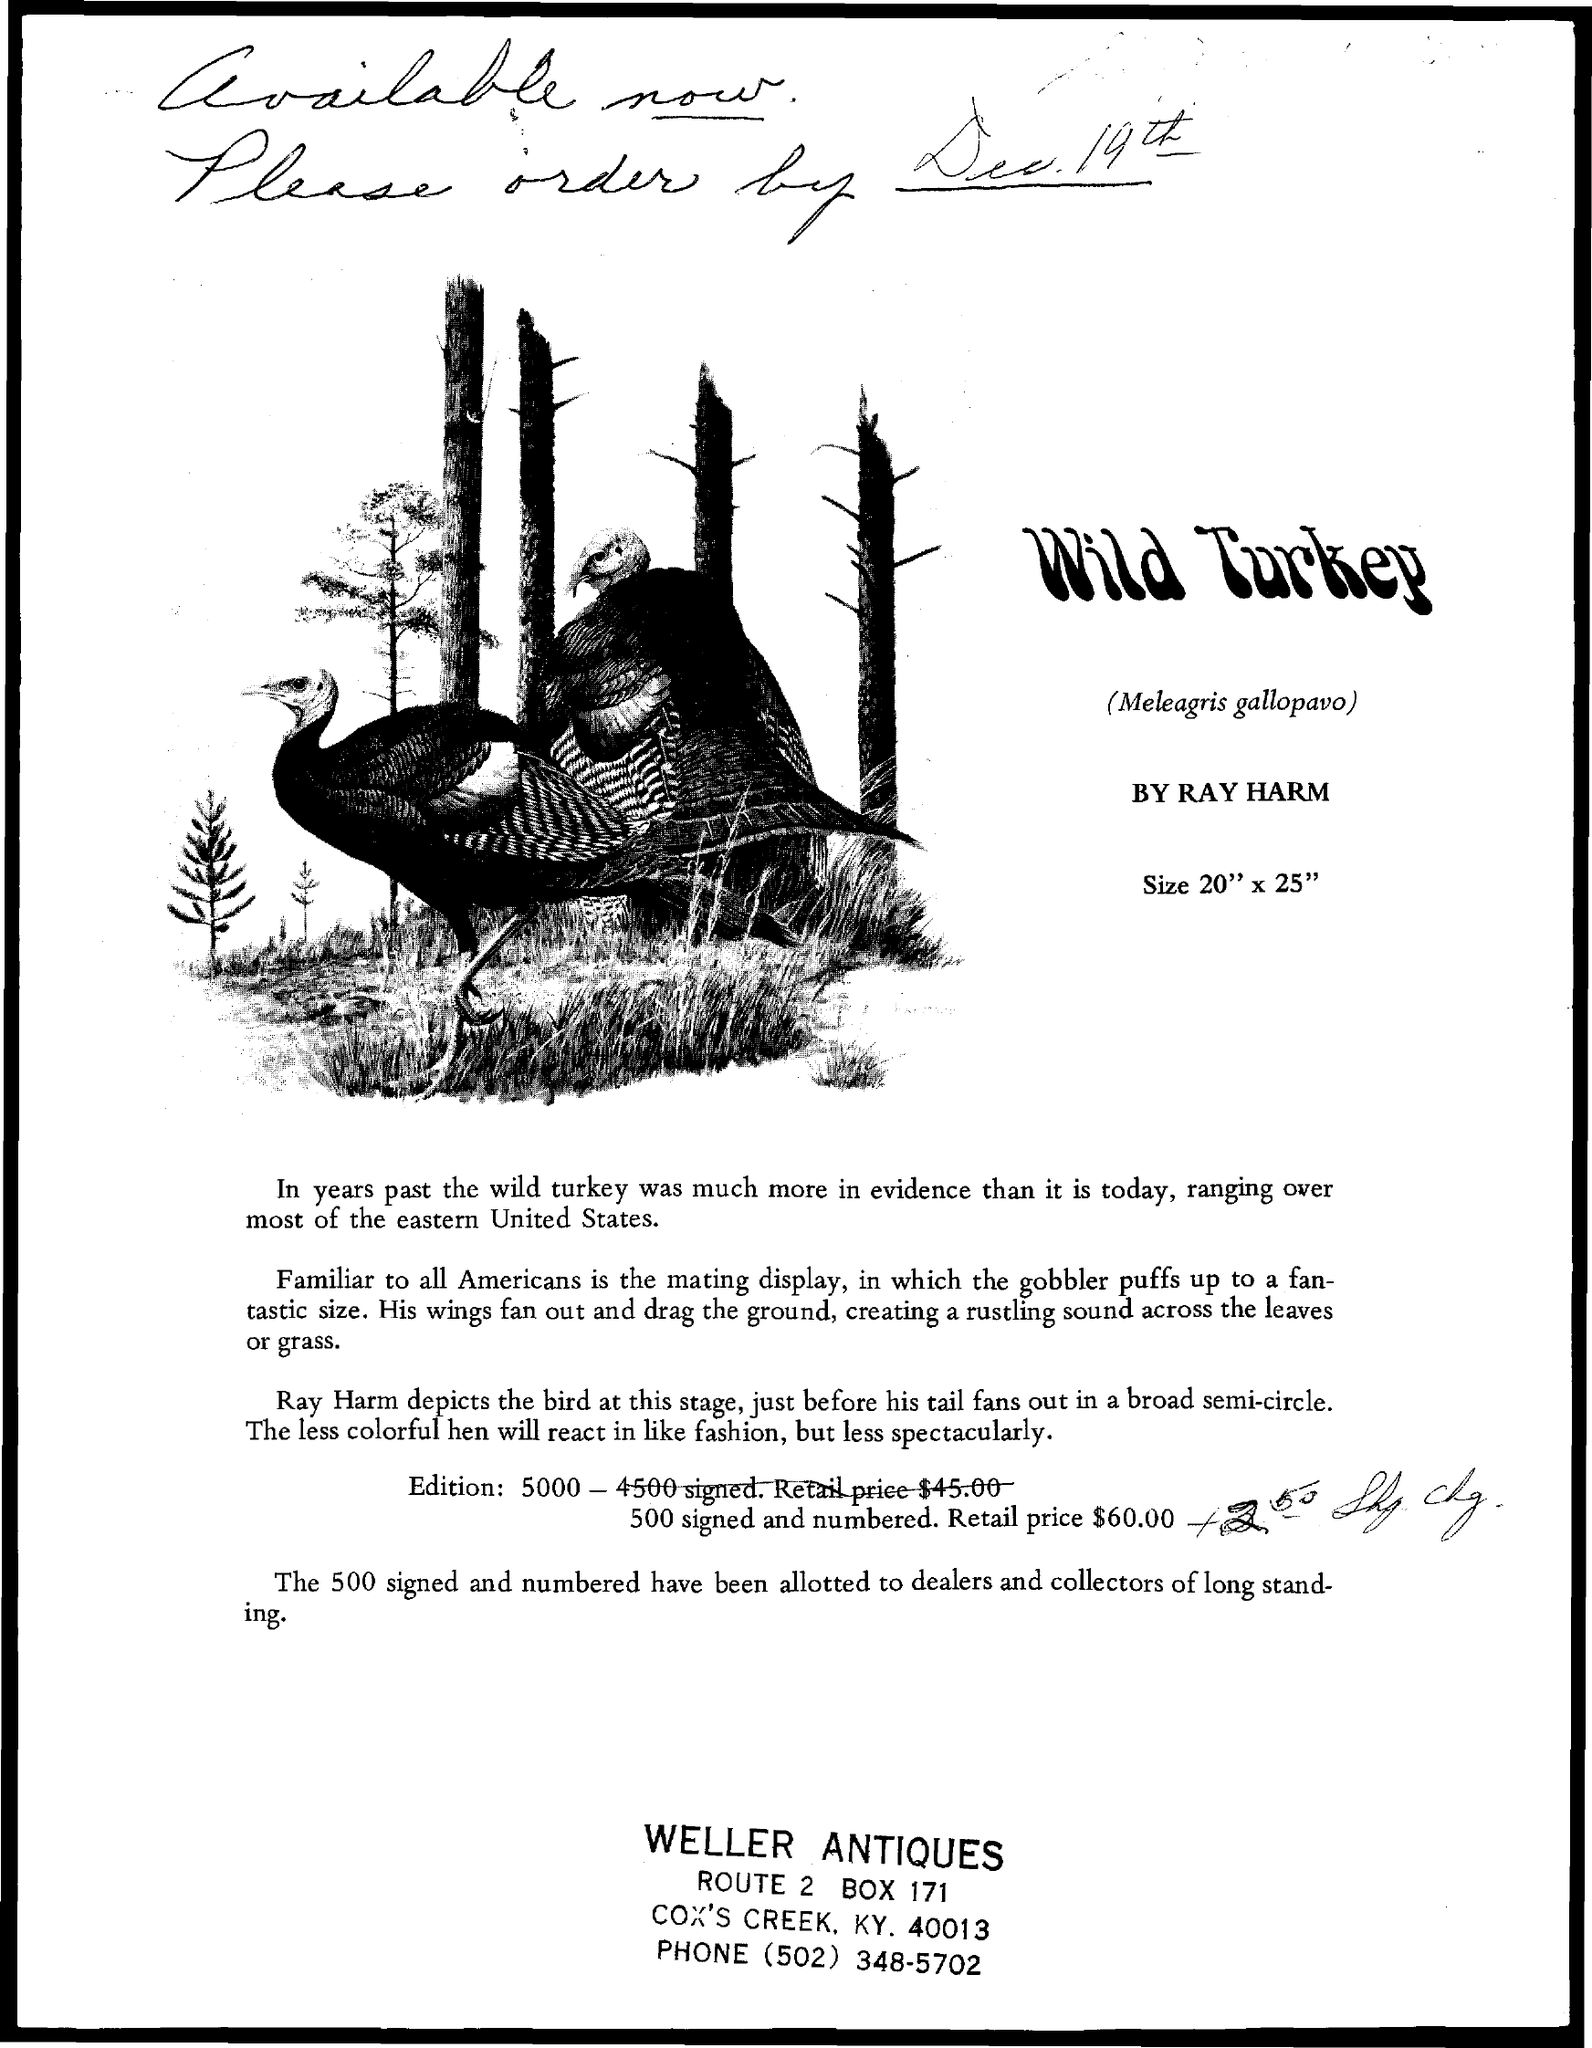What is the BOX Number ?
Offer a very short reply. 171. What is the Phone Number ?
Ensure brevity in your answer.  (502) 348-5702. 